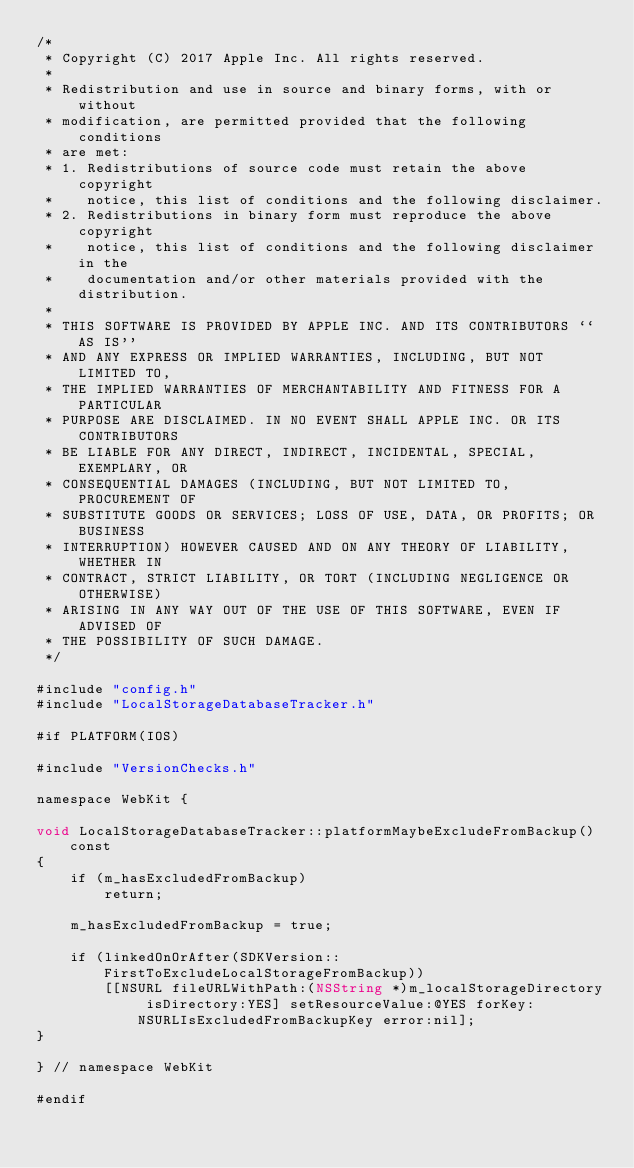Convert code to text. <code><loc_0><loc_0><loc_500><loc_500><_ObjectiveC_>/*
 * Copyright (C) 2017 Apple Inc. All rights reserved.
 *
 * Redistribution and use in source and binary forms, with or without
 * modification, are permitted provided that the following conditions
 * are met:
 * 1. Redistributions of source code must retain the above copyright
 *    notice, this list of conditions and the following disclaimer.
 * 2. Redistributions in binary form must reproduce the above copyright
 *    notice, this list of conditions and the following disclaimer in the
 *    documentation and/or other materials provided with the distribution.
 *
 * THIS SOFTWARE IS PROVIDED BY APPLE INC. AND ITS CONTRIBUTORS ``AS IS''
 * AND ANY EXPRESS OR IMPLIED WARRANTIES, INCLUDING, BUT NOT LIMITED TO,
 * THE IMPLIED WARRANTIES OF MERCHANTABILITY AND FITNESS FOR A PARTICULAR
 * PURPOSE ARE DISCLAIMED. IN NO EVENT SHALL APPLE INC. OR ITS CONTRIBUTORS
 * BE LIABLE FOR ANY DIRECT, INDIRECT, INCIDENTAL, SPECIAL, EXEMPLARY, OR
 * CONSEQUENTIAL DAMAGES (INCLUDING, BUT NOT LIMITED TO, PROCUREMENT OF
 * SUBSTITUTE GOODS OR SERVICES; LOSS OF USE, DATA, OR PROFITS; OR BUSINESS
 * INTERRUPTION) HOWEVER CAUSED AND ON ANY THEORY OF LIABILITY, WHETHER IN
 * CONTRACT, STRICT LIABILITY, OR TORT (INCLUDING NEGLIGENCE OR OTHERWISE)
 * ARISING IN ANY WAY OUT OF THE USE OF THIS SOFTWARE, EVEN IF ADVISED OF
 * THE POSSIBILITY OF SUCH DAMAGE.
 */

#include "config.h"
#include "LocalStorageDatabaseTracker.h"

#if PLATFORM(IOS)

#include "VersionChecks.h"

namespace WebKit {

void LocalStorageDatabaseTracker::platformMaybeExcludeFromBackup() const
{
    if (m_hasExcludedFromBackup)
        return;

    m_hasExcludedFromBackup = true;

    if (linkedOnOrAfter(SDKVersion::FirstToExcludeLocalStorageFromBackup))
        [[NSURL fileURLWithPath:(NSString *)m_localStorageDirectory isDirectory:YES] setResourceValue:@YES forKey:NSURLIsExcludedFromBackupKey error:nil];
}

} // namespace WebKit

#endif
</code> 